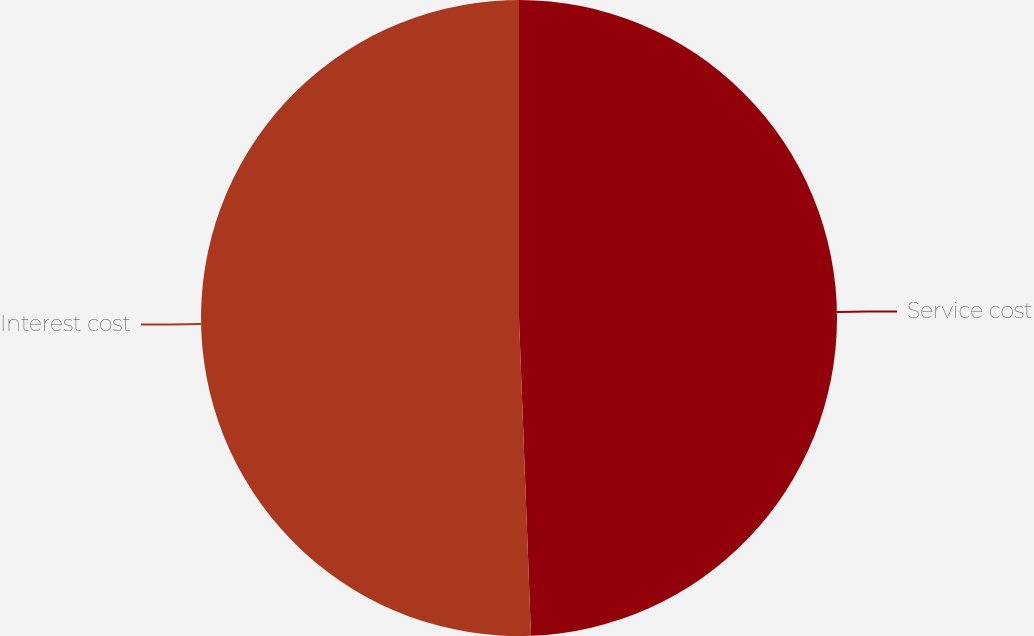Convert chart. <chart><loc_0><loc_0><loc_500><loc_500><pie_chart><fcel>Service cost<fcel>Interest cost<nl><fcel>49.4%<fcel>50.6%<nl></chart> 